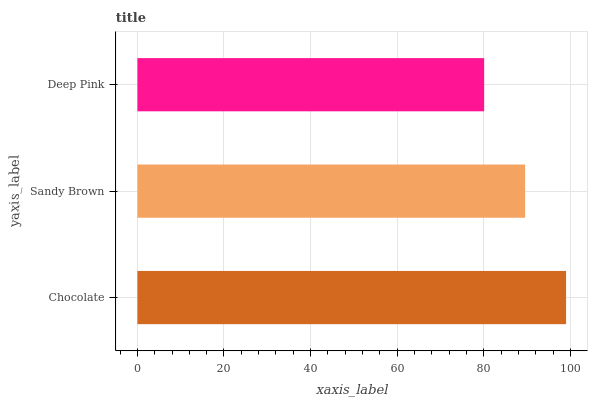Is Deep Pink the minimum?
Answer yes or no. Yes. Is Chocolate the maximum?
Answer yes or no. Yes. Is Sandy Brown the minimum?
Answer yes or no. No. Is Sandy Brown the maximum?
Answer yes or no. No. Is Chocolate greater than Sandy Brown?
Answer yes or no. Yes. Is Sandy Brown less than Chocolate?
Answer yes or no. Yes. Is Sandy Brown greater than Chocolate?
Answer yes or no. No. Is Chocolate less than Sandy Brown?
Answer yes or no. No. Is Sandy Brown the high median?
Answer yes or no. Yes. Is Sandy Brown the low median?
Answer yes or no. Yes. Is Deep Pink the high median?
Answer yes or no. No. Is Deep Pink the low median?
Answer yes or no. No. 